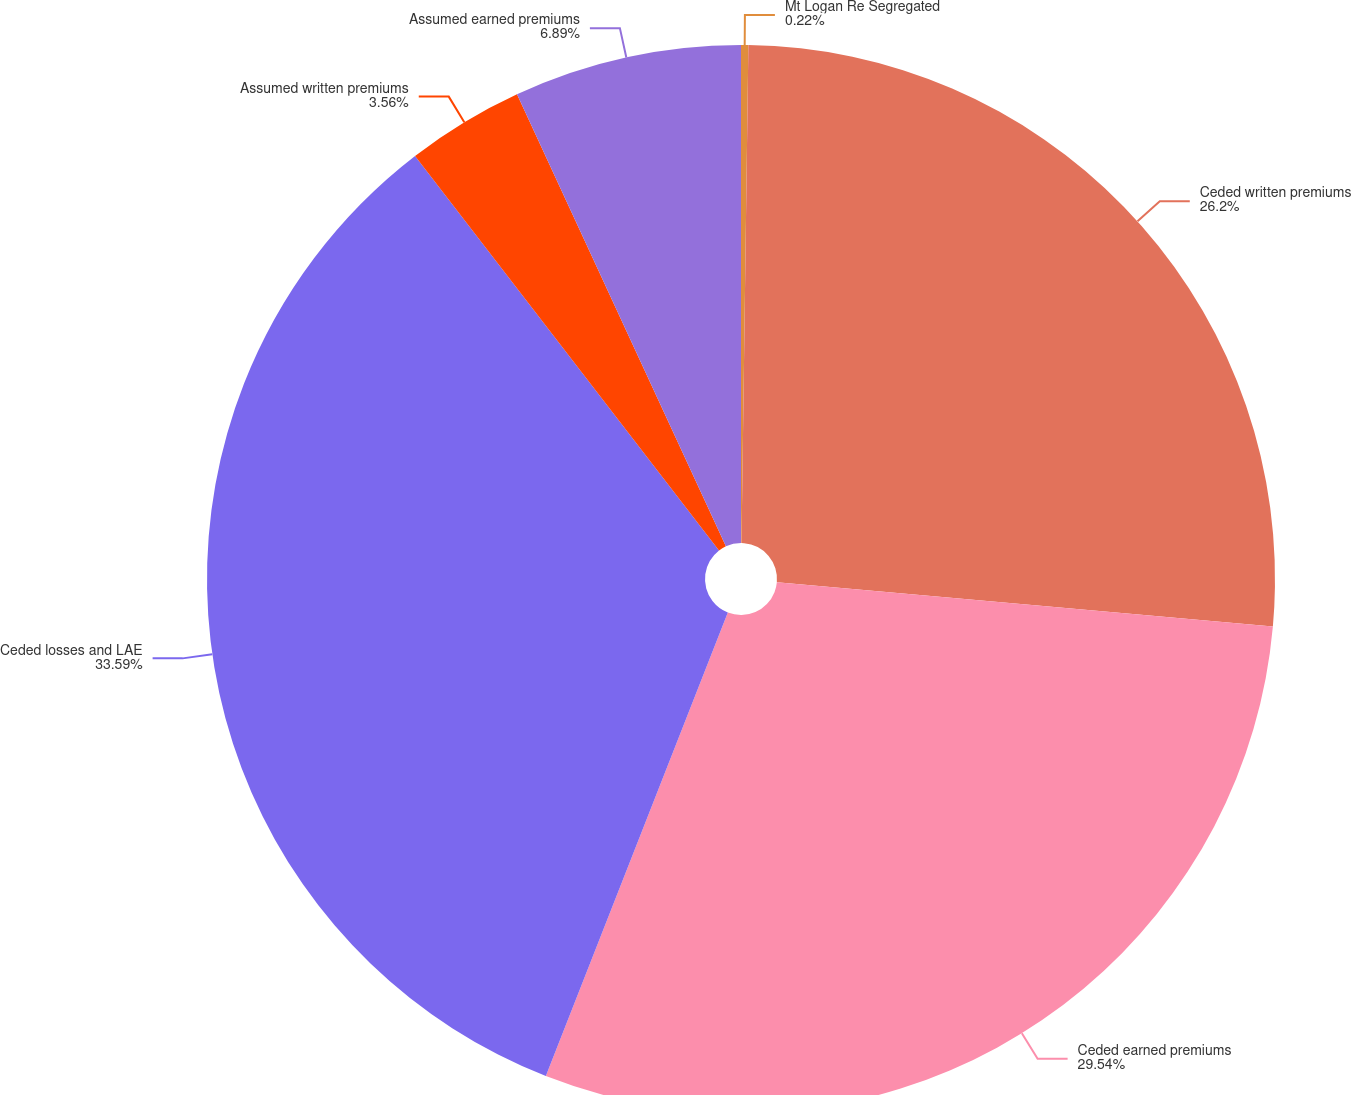<chart> <loc_0><loc_0><loc_500><loc_500><pie_chart><fcel>Mt Logan Re Segregated<fcel>Ceded written premiums<fcel>Ceded earned premiums<fcel>Ceded losses and LAE<fcel>Assumed written premiums<fcel>Assumed earned premiums<nl><fcel>0.22%<fcel>26.2%<fcel>29.54%<fcel>33.6%<fcel>3.56%<fcel>6.89%<nl></chart> 